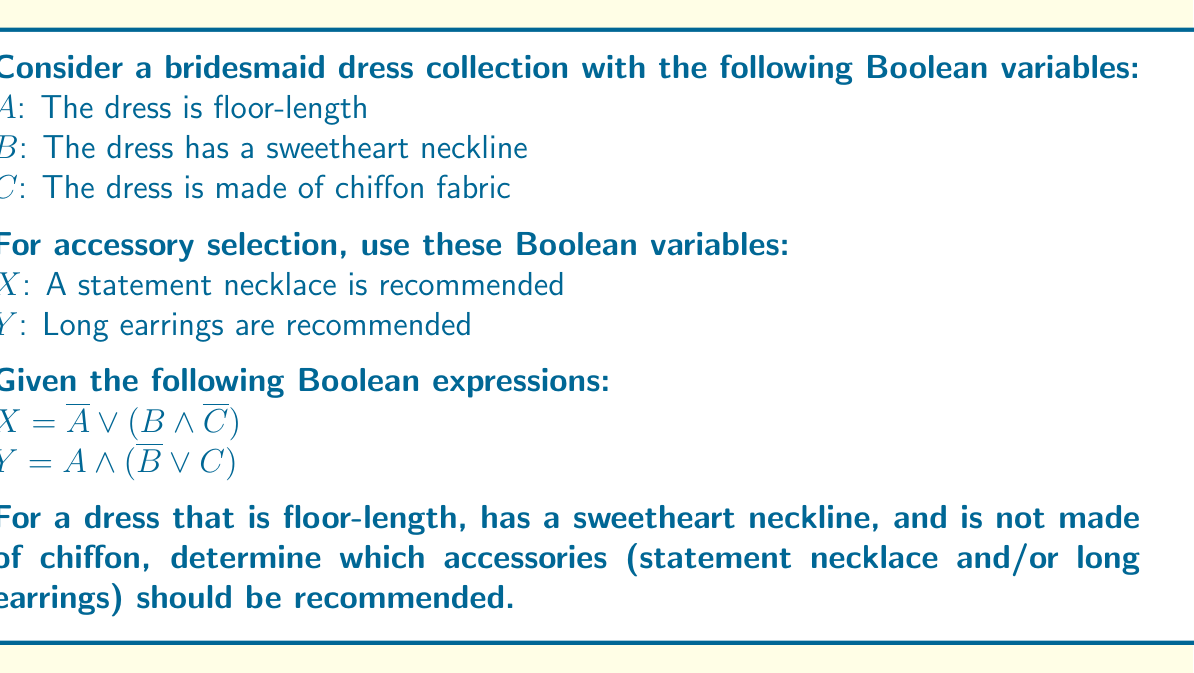Could you help me with this problem? Let's approach this step-by-step:

1) First, we need to determine the values of $A$, $B$, and $C$ based on the given dress description:
   $A = 1$ (the dress is floor-length)
   $B = 1$ (the dress has a sweetheart neckline)
   $C = 0$ (the dress is not made of chiffon)

2) Now, let's evaluate the expression for $X$:
   $X = \overline{A} \lor (B \land \overline{C})$
   
   Substituting the values:
   $X = \overline{1} \lor (1 \land \overline{0})$
   $= 0 \lor (1 \land 1)$
   $= 0 \lor 1$
   $= 1$

3) Next, let's evaluate the expression for $Y$:
   $Y = A \land (\overline{B} \lor C)$
   
   Substituting the values:
   $Y = 1 \land (\overline{1} \lor 0)$
   $= 1 \land (0 \lor 0)$
   $= 1 \land 0$
   $= 0$

4) Interpreting the results:
   $X = 1$ means a statement necklace is recommended
   $Y = 0$ means long earrings are not recommended

Therefore, for this particular dress style, a statement necklace should be recommended, but long earrings should not be recommended.
Answer: Recommend statement necklace only 